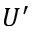<formula> <loc_0><loc_0><loc_500><loc_500>U ^ { \prime }</formula> 